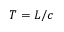<formula> <loc_0><loc_0><loc_500><loc_500>T = L / c</formula> 